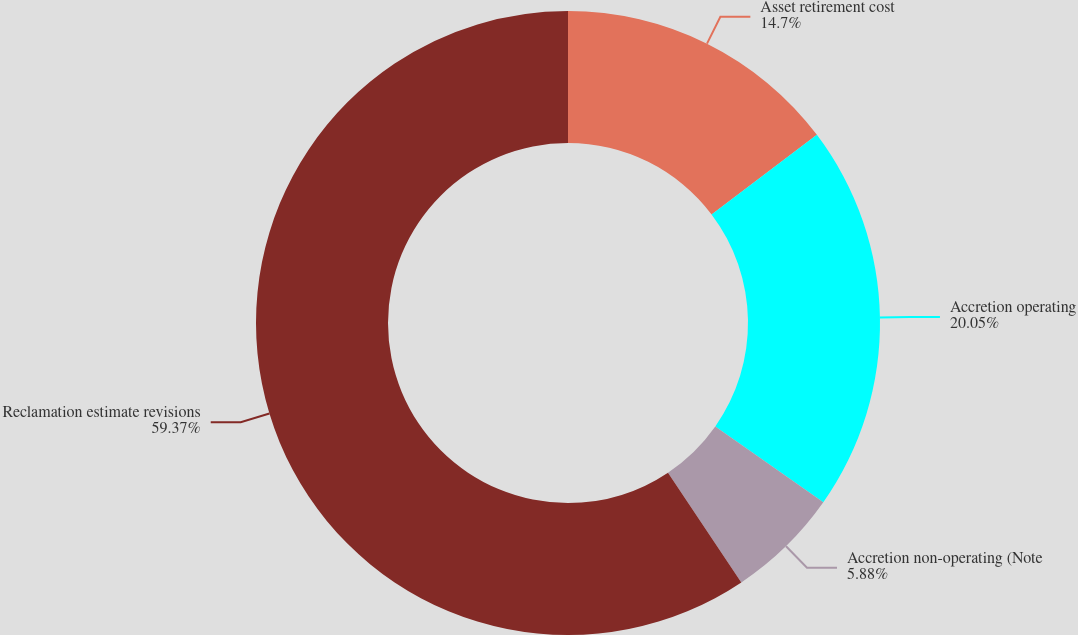<chart> <loc_0><loc_0><loc_500><loc_500><pie_chart><fcel>Asset retirement cost<fcel>Accretion operating<fcel>Accretion non-operating (Note<fcel>Reclamation estimate revisions<nl><fcel>14.7%<fcel>20.05%<fcel>5.88%<fcel>59.38%<nl></chart> 